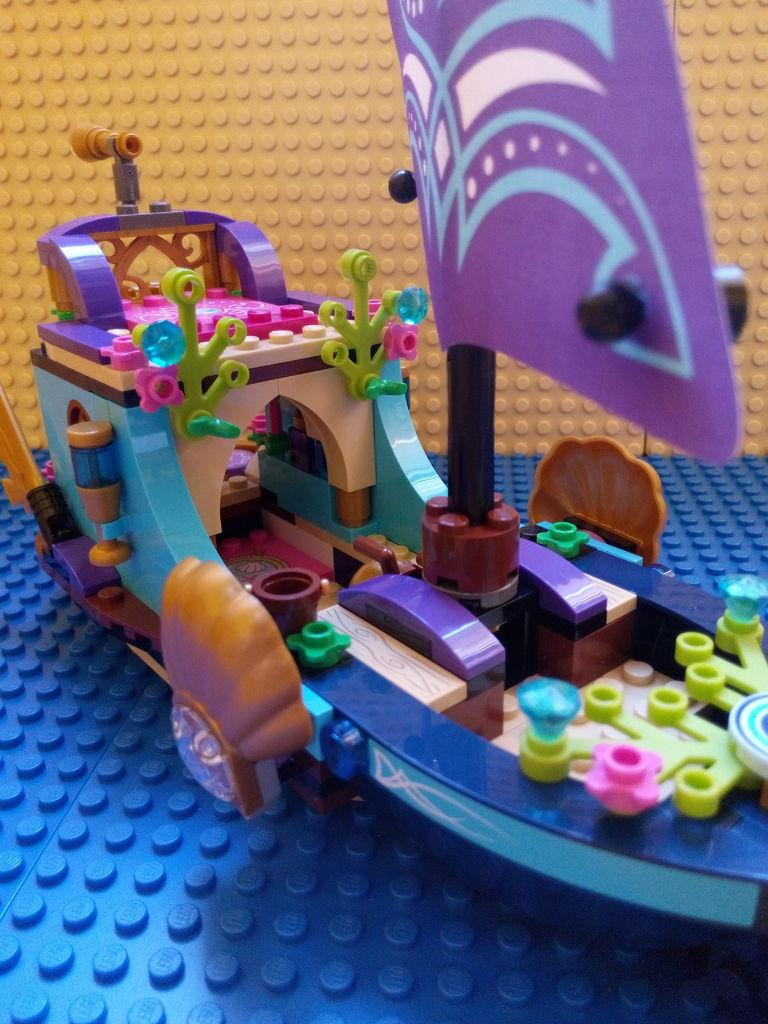What is the main subject in the center of the image? There is a boat toy in the center of the image. How many dolls are present in the rainstorm depicted in the image? There is no rainstorm or dolls present in the image; it features a boat toy. What is the best way to reach the boat toy in the image? The image is a still image, so there is no need to reach the boat toy. 